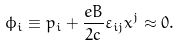<formula> <loc_0><loc_0><loc_500><loc_500>\phi _ { i } \equiv p _ { i } + \frac { e B } { 2 c } \varepsilon _ { i j } x ^ { j } \approx 0 .</formula> 